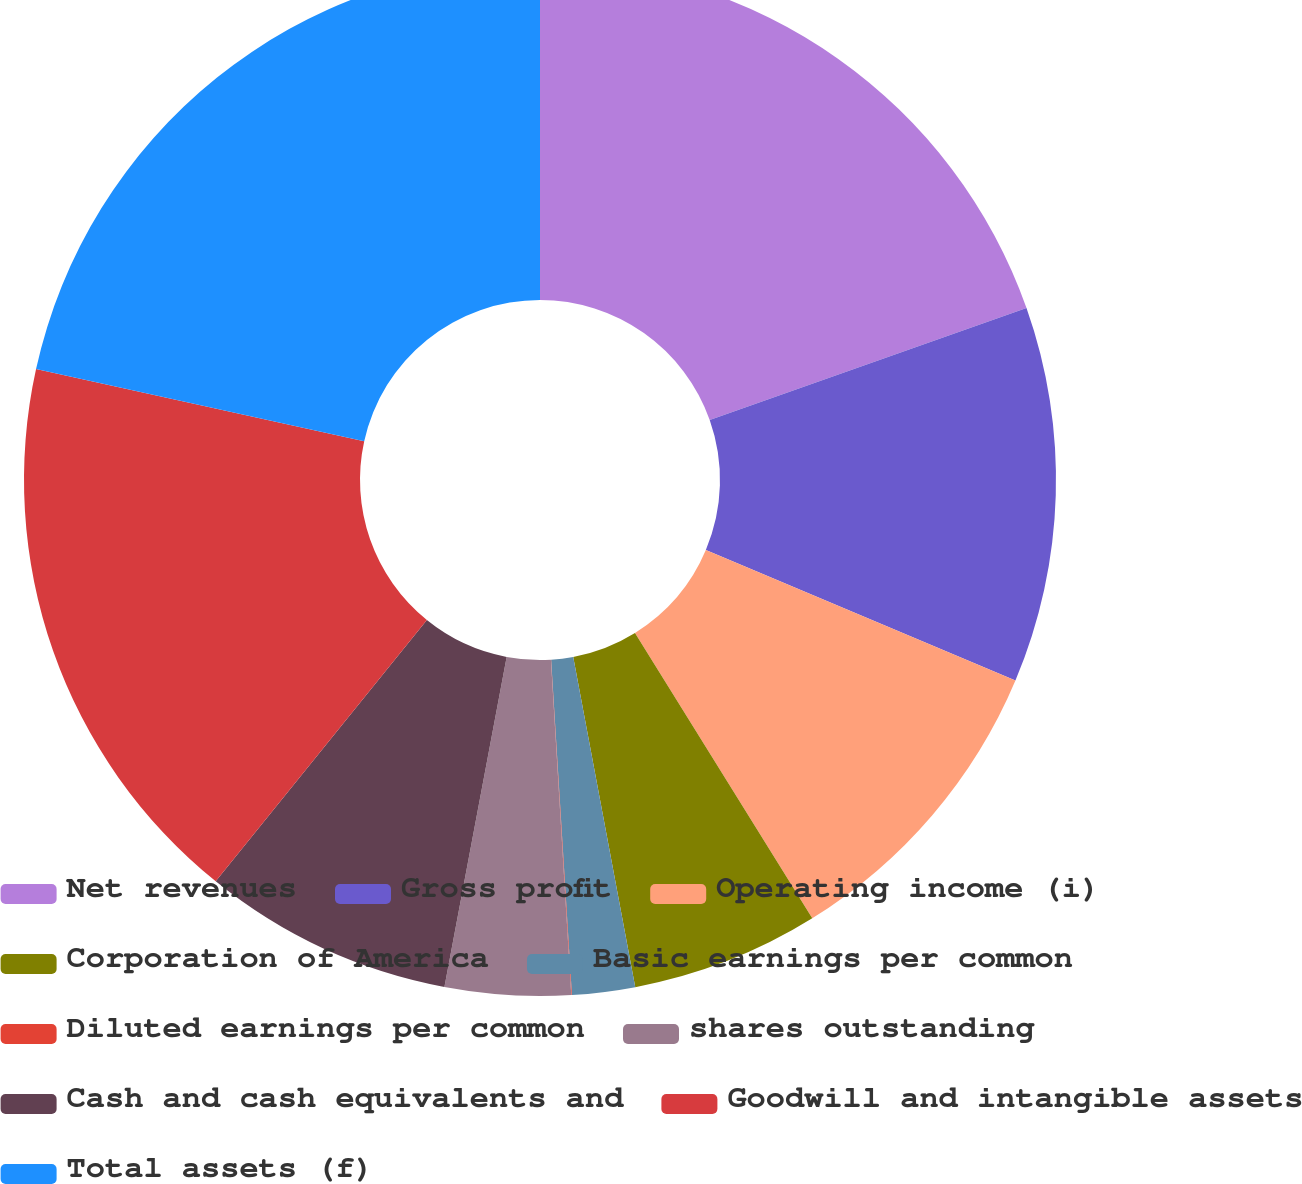<chart> <loc_0><loc_0><loc_500><loc_500><pie_chart><fcel>Net revenues<fcel>Gross profit<fcel>Operating income (i)<fcel>Corporation of America<fcel>Basic earnings per common<fcel>Diluted earnings per common<fcel>shares outstanding<fcel>Cash and cash equivalents and<fcel>Goodwill and intangible assets<fcel>Total assets (f)<nl><fcel>19.59%<fcel>11.76%<fcel>9.8%<fcel>5.89%<fcel>1.97%<fcel>0.02%<fcel>3.93%<fcel>7.85%<fcel>17.63%<fcel>21.55%<nl></chart> 